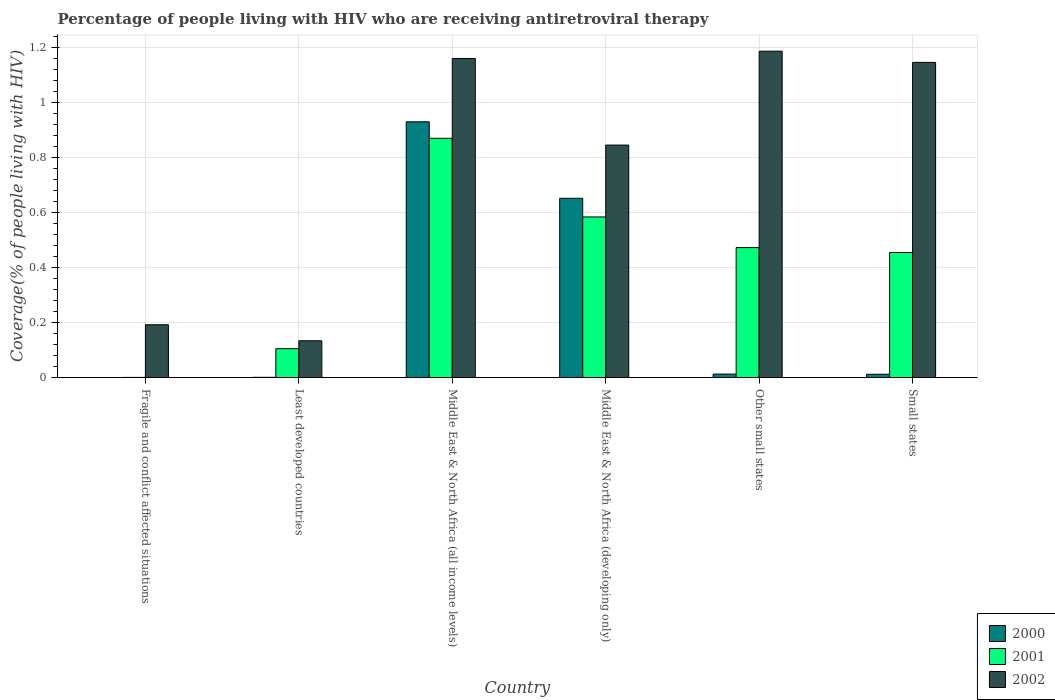How many groups of bars are there?
Give a very brief answer. 6. Are the number of bars per tick equal to the number of legend labels?
Offer a very short reply. Yes. How many bars are there on the 6th tick from the right?
Provide a succinct answer. 3. What is the label of the 3rd group of bars from the left?
Offer a very short reply. Middle East & North Africa (all income levels). In how many cases, is the number of bars for a given country not equal to the number of legend labels?
Keep it short and to the point. 0. What is the percentage of the HIV infected people who are receiving antiretroviral therapy in 2000 in Small states?
Offer a very short reply. 0.01. Across all countries, what is the maximum percentage of the HIV infected people who are receiving antiretroviral therapy in 2000?
Your response must be concise. 0.93. Across all countries, what is the minimum percentage of the HIV infected people who are receiving antiretroviral therapy in 2000?
Your answer should be very brief. 0. In which country was the percentage of the HIV infected people who are receiving antiretroviral therapy in 2000 maximum?
Your answer should be compact. Middle East & North Africa (all income levels). In which country was the percentage of the HIV infected people who are receiving antiretroviral therapy in 2000 minimum?
Your response must be concise. Fragile and conflict affected situations. What is the total percentage of the HIV infected people who are receiving antiretroviral therapy in 2002 in the graph?
Offer a terse response. 4.67. What is the difference between the percentage of the HIV infected people who are receiving antiretroviral therapy in 2000 in Fragile and conflict affected situations and that in Other small states?
Your response must be concise. -0.01. What is the difference between the percentage of the HIV infected people who are receiving antiretroviral therapy in 2001 in Other small states and the percentage of the HIV infected people who are receiving antiretroviral therapy in 2000 in Fragile and conflict affected situations?
Your answer should be very brief. 0.47. What is the average percentage of the HIV infected people who are receiving antiretroviral therapy in 2002 per country?
Your response must be concise. 0.78. What is the difference between the percentage of the HIV infected people who are receiving antiretroviral therapy of/in 2001 and percentage of the HIV infected people who are receiving antiretroviral therapy of/in 2000 in Other small states?
Give a very brief answer. 0.46. What is the ratio of the percentage of the HIV infected people who are receiving antiretroviral therapy in 2001 in Fragile and conflict affected situations to that in Other small states?
Provide a short and direct response. 0. Is the percentage of the HIV infected people who are receiving antiretroviral therapy in 2002 in Middle East & North Africa (all income levels) less than that in Middle East & North Africa (developing only)?
Your response must be concise. No. What is the difference between the highest and the second highest percentage of the HIV infected people who are receiving antiretroviral therapy in 2000?
Provide a succinct answer. 0.28. What is the difference between the highest and the lowest percentage of the HIV infected people who are receiving antiretroviral therapy in 2002?
Your answer should be compact. 1.05. Is the sum of the percentage of the HIV infected people who are receiving antiretroviral therapy in 2002 in Other small states and Small states greater than the maximum percentage of the HIV infected people who are receiving antiretroviral therapy in 2000 across all countries?
Give a very brief answer. Yes. What does the 1st bar from the left in Other small states represents?
Your answer should be compact. 2000. What does the 1st bar from the right in Least developed countries represents?
Keep it short and to the point. 2002. Is it the case that in every country, the sum of the percentage of the HIV infected people who are receiving antiretroviral therapy in 2002 and percentage of the HIV infected people who are receiving antiretroviral therapy in 2000 is greater than the percentage of the HIV infected people who are receiving antiretroviral therapy in 2001?
Provide a succinct answer. Yes. How many countries are there in the graph?
Ensure brevity in your answer.  6. Are the values on the major ticks of Y-axis written in scientific E-notation?
Your response must be concise. No. Does the graph contain any zero values?
Provide a succinct answer. No. Does the graph contain grids?
Provide a succinct answer. Yes. How are the legend labels stacked?
Offer a terse response. Vertical. What is the title of the graph?
Give a very brief answer. Percentage of people living with HIV who are receiving antiretroviral therapy. What is the label or title of the X-axis?
Provide a short and direct response. Country. What is the label or title of the Y-axis?
Your response must be concise. Coverage(% of people living with HIV). What is the Coverage(% of people living with HIV) of 2000 in Fragile and conflict affected situations?
Make the answer very short. 0. What is the Coverage(% of people living with HIV) in 2001 in Fragile and conflict affected situations?
Your answer should be very brief. 0. What is the Coverage(% of people living with HIV) of 2002 in Fragile and conflict affected situations?
Make the answer very short. 0.19. What is the Coverage(% of people living with HIV) of 2000 in Least developed countries?
Offer a very short reply. 0. What is the Coverage(% of people living with HIV) of 2001 in Least developed countries?
Your answer should be very brief. 0.11. What is the Coverage(% of people living with HIV) of 2002 in Least developed countries?
Give a very brief answer. 0.13. What is the Coverage(% of people living with HIV) of 2000 in Middle East & North Africa (all income levels)?
Keep it short and to the point. 0.93. What is the Coverage(% of people living with HIV) of 2001 in Middle East & North Africa (all income levels)?
Provide a short and direct response. 0.87. What is the Coverage(% of people living with HIV) of 2002 in Middle East & North Africa (all income levels)?
Your response must be concise. 1.16. What is the Coverage(% of people living with HIV) of 2000 in Middle East & North Africa (developing only)?
Offer a very short reply. 0.65. What is the Coverage(% of people living with HIV) in 2001 in Middle East & North Africa (developing only)?
Give a very brief answer. 0.58. What is the Coverage(% of people living with HIV) in 2002 in Middle East & North Africa (developing only)?
Offer a very short reply. 0.85. What is the Coverage(% of people living with HIV) in 2000 in Other small states?
Provide a succinct answer. 0.01. What is the Coverage(% of people living with HIV) in 2001 in Other small states?
Make the answer very short. 0.47. What is the Coverage(% of people living with HIV) in 2002 in Other small states?
Offer a very short reply. 1.19. What is the Coverage(% of people living with HIV) in 2000 in Small states?
Give a very brief answer. 0.01. What is the Coverage(% of people living with HIV) in 2001 in Small states?
Give a very brief answer. 0.45. What is the Coverage(% of people living with HIV) in 2002 in Small states?
Provide a succinct answer. 1.15. Across all countries, what is the maximum Coverage(% of people living with HIV) of 2000?
Provide a short and direct response. 0.93. Across all countries, what is the maximum Coverage(% of people living with HIV) in 2001?
Your answer should be compact. 0.87. Across all countries, what is the maximum Coverage(% of people living with HIV) of 2002?
Keep it short and to the point. 1.19. Across all countries, what is the minimum Coverage(% of people living with HIV) in 2000?
Give a very brief answer. 0. Across all countries, what is the minimum Coverage(% of people living with HIV) in 2001?
Ensure brevity in your answer.  0. Across all countries, what is the minimum Coverage(% of people living with HIV) in 2002?
Ensure brevity in your answer.  0.13. What is the total Coverage(% of people living with HIV) in 2000 in the graph?
Provide a short and direct response. 1.61. What is the total Coverage(% of people living with HIV) in 2001 in the graph?
Your response must be concise. 2.49. What is the total Coverage(% of people living with HIV) of 2002 in the graph?
Your answer should be compact. 4.67. What is the difference between the Coverage(% of people living with HIV) in 2000 in Fragile and conflict affected situations and that in Least developed countries?
Offer a very short reply. -0. What is the difference between the Coverage(% of people living with HIV) in 2001 in Fragile and conflict affected situations and that in Least developed countries?
Offer a terse response. -0.1. What is the difference between the Coverage(% of people living with HIV) of 2002 in Fragile and conflict affected situations and that in Least developed countries?
Offer a terse response. 0.06. What is the difference between the Coverage(% of people living with HIV) in 2000 in Fragile and conflict affected situations and that in Middle East & North Africa (all income levels)?
Provide a succinct answer. -0.93. What is the difference between the Coverage(% of people living with HIV) of 2001 in Fragile and conflict affected situations and that in Middle East & North Africa (all income levels)?
Your answer should be very brief. -0.87. What is the difference between the Coverage(% of people living with HIV) of 2002 in Fragile and conflict affected situations and that in Middle East & North Africa (all income levels)?
Make the answer very short. -0.97. What is the difference between the Coverage(% of people living with HIV) of 2000 in Fragile and conflict affected situations and that in Middle East & North Africa (developing only)?
Your response must be concise. -0.65. What is the difference between the Coverage(% of people living with HIV) of 2001 in Fragile and conflict affected situations and that in Middle East & North Africa (developing only)?
Your answer should be very brief. -0.58. What is the difference between the Coverage(% of people living with HIV) in 2002 in Fragile and conflict affected situations and that in Middle East & North Africa (developing only)?
Give a very brief answer. -0.65. What is the difference between the Coverage(% of people living with HIV) in 2000 in Fragile and conflict affected situations and that in Other small states?
Provide a succinct answer. -0.01. What is the difference between the Coverage(% of people living with HIV) of 2001 in Fragile and conflict affected situations and that in Other small states?
Offer a terse response. -0.47. What is the difference between the Coverage(% of people living with HIV) in 2002 in Fragile and conflict affected situations and that in Other small states?
Your answer should be very brief. -0.99. What is the difference between the Coverage(% of people living with HIV) of 2000 in Fragile and conflict affected situations and that in Small states?
Offer a very short reply. -0.01. What is the difference between the Coverage(% of people living with HIV) of 2001 in Fragile and conflict affected situations and that in Small states?
Provide a succinct answer. -0.45. What is the difference between the Coverage(% of people living with HIV) in 2002 in Fragile and conflict affected situations and that in Small states?
Your answer should be very brief. -0.95. What is the difference between the Coverage(% of people living with HIV) of 2000 in Least developed countries and that in Middle East & North Africa (all income levels)?
Your answer should be compact. -0.93. What is the difference between the Coverage(% of people living with HIV) of 2001 in Least developed countries and that in Middle East & North Africa (all income levels)?
Provide a succinct answer. -0.76. What is the difference between the Coverage(% of people living with HIV) of 2002 in Least developed countries and that in Middle East & North Africa (all income levels)?
Your answer should be compact. -1.03. What is the difference between the Coverage(% of people living with HIV) of 2000 in Least developed countries and that in Middle East & North Africa (developing only)?
Keep it short and to the point. -0.65. What is the difference between the Coverage(% of people living with HIV) in 2001 in Least developed countries and that in Middle East & North Africa (developing only)?
Your response must be concise. -0.48. What is the difference between the Coverage(% of people living with HIV) in 2002 in Least developed countries and that in Middle East & North Africa (developing only)?
Provide a short and direct response. -0.71. What is the difference between the Coverage(% of people living with HIV) in 2000 in Least developed countries and that in Other small states?
Your answer should be compact. -0.01. What is the difference between the Coverage(% of people living with HIV) in 2001 in Least developed countries and that in Other small states?
Your answer should be very brief. -0.37. What is the difference between the Coverage(% of people living with HIV) of 2002 in Least developed countries and that in Other small states?
Offer a very short reply. -1.05. What is the difference between the Coverage(% of people living with HIV) of 2000 in Least developed countries and that in Small states?
Offer a very short reply. -0.01. What is the difference between the Coverage(% of people living with HIV) in 2001 in Least developed countries and that in Small states?
Keep it short and to the point. -0.35. What is the difference between the Coverage(% of people living with HIV) in 2002 in Least developed countries and that in Small states?
Your answer should be very brief. -1.01. What is the difference between the Coverage(% of people living with HIV) in 2000 in Middle East & North Africa (all income levels) and that in Middle East & North Africa (developing only)?
Your answer should be very brief. 0.28. What is the difference between the Coverage(% of people living with HIV) of 2001 in Middle East & North Africa (all income levels) and that in Middle East & North Africa (developing only)?
Your answer should be very brief. 0.29. What is the difference between the Coverage(% of people living with HIV) in 2002 in Middle East & North Africa (all income levels) and that in Middle East & North Africa (developing only)?
Provide a succinct answer. 0.31. What is the difference between the Coverage(% of people living with HIV) in 2000 in Middle East & North Africa (all income levels) and that in Other small states?
Ensure brevity in your answer.  0.92. What is the difference between the Coverage(% of people living with HIV) in 2001 in Middle East & North Africa (all income levels) and that in Other small states?
Your answer should be very brief. 0.4. What is the difference between the Coverage(% of people living with HIV) of 2002 in Middle East & North Africa (all income levels) and that in Other small states?
Your answer should be compact. -0.03. What is the difference between the Coverage(% of people living with HIV) in 2000 in Middle East & North Africa (all income levels) and that in Small states?
Give a very brief answer. 0.92. What is the difference between the Coverage(% of people living with HIV) of 2001 in Middle East & North Africa (all income levels) and that in Small states?
Offer a very short reply. 0.42. What is the difference between the Coverage(% of people living with HIV) of 2002 in Middle East & North Africa (all income levels) and that in Small states?
Keep it short and to the point. 0.01. What is the difference between the Coverage(% of people living with HIV) in 2000 in Middle East & North Africa (developing only) and that in Other small states?
Give a very brief answer. 0.64. What is the difference between the Coverage(% of people living with HIV) in 2001 in Middle East & North Africa (developing only) and that in Other small states?
Provide a short and direct response. 0.11. What is the difference between the Coverage(% of people living with HIV) in 2002 in Middle East & North Africa (developing only) and that in Other small states?
Offer a terse response. -0.34. What is the difference between the Coverage(% of people living with HIV) of 2000 in Middle East & North Africa (developing only) and that in Small states?
Your answer should be very brief. 0.64. What is the difference between the Coverage(% of people living with HIV) in 2001 in Middle East & North Africa (developing only) and that in Small states?
Ensure brevity in your answer.  0.13. What is the difference between the Coverage(% of people living with HIV) in 2002 in Middle East & North Africa (developing only) and that in Small states?
Ensure brevity in your answer.  -0.3. What is the difference between the Coverage(% of people living with HIV) in 2000 in Other small states and that in Small states?
Provide a succinct answer. 0. What is the difference between the Coverage(% of people living with HIV) in 2001 in Other small states and that in Small states?
Offer a terse response. 0.02. What is the difference between the Coverage(% of people living with HIV) in 2002 in Other small states and that in Small states?
Your answer should be compact. 0.04. What is the difference between the Coverage(% of people living with HIV) in 2000 in Fragile and conflict affected situations and the Coverage(% of people living with HIV) in 2001 in Least developed countries?
Make the answer very short. -0.1. What is the difference between the Coverage(% of people living with HIV) in 2000 in Fragile and conflict affected situations and the Coverage(% of people living with HIV) in 2002 in Least developed countries?
Your answer should be very brief. -0.13. What is the difference between the Coverage(% of people living with HIV) in 2001 in Fragile and conflict affected situations and the Coverage(% of people living with HIV) in 2002 in Least developed countries?
Provide a succinct answer. -0.13. What is the difference between the Coverage(% of people living with HIV) of 2000 in Fragile and conflict affected situations and the Coverage(% of people living with HIV) of 2001 in Middle East & North Africa (all income levels)?
Provide a succinct answer. -0.87. What is the difference between the Coverage(% of people living with HIV) in 2000 in Fragile and conflict affected situations and the Coverage(% of people living with HIV) in 2002 in Middle East & North Africa (all income levels)?
Provide a short and direct response. -1.16. What is the difference between the Coverage(% of people living with HIV) of 2001 in Fragile and conflict affected situations and the Coverage(% of people living with HIV) of 2002 in Middle East & North Africa (all income levels)?
Offer a terse response. -1.16. What is the difference between the Coverage(% of people living with HIV) of 2000 in Fragile and conflict affected situations and the Coverage(% of people living with HIV) of 2001 in Middle East & North Africa (developing only)?
Offer a very short reply. -0.58. What is the difference between the Coverage(% of people living with HIV) of 2000 in Fragile and conflict affected situations and the Coverage(% of people living with HIV) of 2002 in Middle East & North Africa (developing only)?
Keep it short and to the point. -0.85. What is the difference between the Coverage(% of people living with HIV) of 2001 in Fragile and conflict affected situations and the Coverage(% of people living with HIV) of 2002 in Middle East & North Africa (developing only)?
Provide a succinct answer. -0.84. What is the difference between the Coverage(% of people living with HIV) in 2000 in Fragile and conflict affected situations and the Coverage(% of people living with HIV) in 2001 in Other small states?
Your response must be concise. -0.47. What is the difference between the Coverage(% of people living with HIV) in 2000 in Fragile and conflict affected situations and the Coverage(% of people living with HIV) in 2002 in Other small states?
Your response must be concise. -1.19. What is the difference between the Coverage(% of people living with HIV) of 2001 in Fragile and conflict affected situations and the Coverage(% of people living with HIV) of 2002 in Other small states?
Your answer should be compact. -1.19. What is the difference between the Coverage(% of people living with HIV) of 2000 in Fragile and conflict affected situations and the Coverage(% of people living with HIV) of 2001 in Small states?
Provide a short and direct response. -0.45. What is the difference between the Coverage(% of people living with HIV) of 2000 in Fragile and conflict affected situations and the Coverage(% of people living with HIV) of 2002 in Small states?
Your answer should be very brief. -1.15. What is the difference between the Coverage(% of people living with HIV) of 2001 in Fragile and conflict affected situations and the Coverage(% of people living with HIV) of 2002 in Small states?
Give a very brief answer. -1.15. What is the difference between the Coverage(% of people living with HIV) of 2000 in Least developed countries and the Coverage(% of people living with HIV) of 2001 in Middle East & North Africa (all income levels)?
Provide a succinct answer. -0.87. What is the difference between the Coverage(% of people living with HIV) of 2000 in Least developed countries and the Coverage(% of people living with HIV) of 2002 in Middle East & North Africa (all income levels)?
Offer a terse response. -1.16. What is the difference between the Coverage(% of people living with HIV) of 2001 in Least developed countries and the Coverage(% of people living with HIV) of 2002 in Middle East & North Africa (all income levels)?
Your answer should be very brief. -1.05. What is the difference between the Coverage(% of people living with HIV) of 2000 in Least developed countries and the Coverage(% of people living with HIV) of 2001 in Middle East & North Africa (developing only)?
Give a very brief answer. -0.58. What is the difference between the Coverage(% of people living with HIV) in 2000 in Least developed countries and the Coverage(% of people living with HIV) in 2002 in Middle East & North Africa (developing only)?
Provide a short and direct response. -0.84. What is the difference between the Coverage(% of people living with HIV) of 2001 in Least developed countries and the Coverage(% of people living with HIV) of 2002 in Middle East & North Africa (developing only)?
Ensure brevity in your answer.  -0.74. What is the difference between the Coverage(% of people living with HIV) in 2000 in Least developed countries and the Coverage(% of people living with HIV) in 2001 in Other small states?
Provide a short and direct response. -0.47. What is the difference between the Coverage(% of people living with HIV) of 2000 in Least developed countries and the Coverage(% of people living with HIV) of 2002 in Other small states?
Your answer should be compact. -1.19. What is the difference between the Coverage(% of people living with HIV) of 2001 in Least developed countries and the Coverage(% of people living with HIV) of 2002 in Other small states?
Keep it short and to the point. -1.08. What is the difference between the Coverage(% of people living with HIV) of 2000 in Least developed countries and the Coverage(% of people living with HIV) of 2001 in Small states?
Your answer should be very brief. -0.45. What is the difference between the Coverage(% of people living with HIV) of 2000 in Least developed countries and the Coverage(% of people living with HIV) of 2002 in Small states?
Ensure brevity in your answer.  -1.14. What is the difference between the Coverage(% of people living with HIV) in 2001 in Least developed countries and the Coverage(% of people living with HIV) in 2002 in Small states?
Ensure brevity in your answer.  -1.04. What is the difference between the Coverage(% of people living with HIV) of 2000 in Middle East & North Africa (all income levels) and the Coverage(% of people living with HIV) of 2001 in Middle East & North Africa (developing only)?
Provide a short and direct response. 0.35. What is the difference between the Coverage(% of people living with HIV) of 2000 in Middle East & North Africa (all income levels) and the Coverage(% of people living with HIV) of 2002 in Middle East & North Africa (developing only)?
Keep it short and to the point. 0.08. What is the difference between the Coverage(% of people living with HIV) of 2001 in Middle East & North Africa (all income levels) and the Coverage(% of people living with HIV) of 2002 in Middle East & North Africa (developing only)?
Offer a terse response. 0.02. What is the difference between the Coverage(% of people living with HIV) in 2000 in Middle East & North Africa (all income levels) and the Coverage(% of people living with HIV) in 2001 in Other small states?
Give a very brief answer. 0.46. What is the difference between the Coverage(% of people living with HIV) of 2000 in Middle East & North Africa (all income levels) and the Coverage(% of people living with HIV) of 2002 in Other small states?
Provide a short and direct response. -0.26. What is the difference between the Coverage(% of people living with HIV) of 2001 in Middle East & North Africa (all income levels) and the Coverage(% of people living with HIV) of 2002 in Other small states?
Ensure brevity in your answer.  -0.32. What is the difference between the Coverage(% of people living with HIV) of 2000 in Middle East & North Africa (all income levels) and the Coverage(% of people living with HIV) of 2001 in Small states?
Your response must be concise. 0.48. What is the difference between the Coverage(% of people living with HIV) in 2000 in Middle East & North Africa (all income levels) and the Coverage(% of people living with HIV) in 2002 in Small states?
Keep it short and to the point. -0.22. What is the difference between the Coverage(% of people living with HIV) in 2001 in Middle East & North Africa (all income levels) and the Coverage(% of people living with HIV) in 2002 in Small states?
Offer a terse response. -0.28. What is the difference between the Coverage(% of people living with HIV) of 2000 in Middle East & North Africa (developing only) and the Coverage(% of people living with HIV) of 2001 in Other small states?
Provide a succinct answer. 0.18. What is the difference between the Coverage(% of people living with HIV) of 2000 in Middle East & North Africa (developing only) and the Coverage(% of people living with HIV) of 2002 in Other small states?
Your response must be concise. -0.53. What is the difference between the Coverage(% of people living with HIV) of 2001 in Middle East & North Africa (developing only) and the Coverage(% of people living with HIV) of 2002 in Other small states?
Your answer should be very brief. -0.6. What is the difference between the Coverage(% of people living with HIV) in 2000 in Middle East & North Africa (developing only) and the Coverage(% of people living with HIV) in 2001 in Small states?
Your answer should be compact. 0.2. What is the difference between the Coverage(% of people living with HIV) of 2000 in Middle East & North Africa (developing only) and the Coverage(% of people living with HIV) of 2002 in Small states?
Ensure brevity in your answer.  -0.49. What is the difference between the Coverage(% of people living with HIV) of 2001 in Middle East & North Africa (developing only) and the Coverage(% of people living with HIV) of 2002 in Small states?
Ensure brevity in your answer.  -0.56. What is the difference between the Coverage(% of people living with HIV) of 2000 in Other small states and the Coverage(% of people living with HIV) of 2001 in Small states?
Provide a succinct answer. -0.44. What is the difference between the Coverage(% of people living with HIV) of 2000 in Other small states and the Coverage(% of people living with HIV) of 2002 in Small states?
Provide a succinct answer. -1.13. What is the difference between the Coverage(% of people living with HIV) of 2001 in Other small states and the Coverage(% of people living with HIV) of 2002 in Small states?
Give a very brief answer. -0.67. What is the average Coverage(% of people living with HIV) in 2000 per country?
Make the answer very short. 0.27. What is the average Coverage(% of people living with HIV) of 2001 per country?
Keep it short and to the point. 0.41. What is the average Coverage(% of people living with HIV) in 2002 per country?
Make the answer very short. 0.78. What is the difference between the Coverage(% of people living with HIV) in 2000 and Coverage(% of people living with HIV) in 2001 in Fragile and conflict affected situations?
Your response must be concise. -0. What is the difference between the Coverage(% of people living with HIV) in 2000 and Coverage(% of people living with HIV) in 2002 in Fragile and conflict affected situations?
Make the answer very short. -0.19. What is the difference between the Coverage(% of people living with HIV) in 2001 and Coverage(% of people living with HIV) in 2002 in Fragile and conflict affected situations?
Provide a short and direct response. -0.19. What is the difference between the Coverage(% of people living with HIV) in 2000 and Coverage(% of people living with HIV) in 2001 in Least developed countries?
Your answer should be compact. -0.1. What is the difference between the Coverage(% of people living with HIV) of 2000 and Coverage(% of people living with HIV) of 2002 in Least developed countries?
Offer a terse response. -0.13. What is the difference between the Coverage(% of people living with HIV) in 2001 and Coverage(% of people living with HIV) in 2002 in Least developed countries?
Offer a very short reply. -0.03. What is the difference between the Coverage(% of people living with HIV) in 2000 and Coverage(% of people living with HIV) in 2001 in Middle East & North Africa (all income levels)?
Make the answer very short. 0.06. What is the difference between the Coverage(% of people living with HIV) of 2000 and Coverage(% of people living with HIV) of 2002 in Middle East & North Africa (all income levels)?
Offer a very short reply. -0.23. What is the difference between the Coverage(% of people living with HIV) of 2001 and Coverage(% of people living with HIV) of 2002 in Middle East & North Africa (all income levels)?
Your answer should be compact. -0.29. What is the difference between the Coverage(% of people living with HIV) of 2000 and Coverage(% of people living with HIV) of 2001 in Middle East & North Africa (developing only)?
Your answer should be very brief. 0.07. What is the difference between the Coverage(% of people living with HIV) of 2000 and Coverage(% of people living with HIV) of 2002 in Middle East & North Africa (developing only)?
Offer a terse response. -0.19. What is the difference between the Coverage(% of people living with HIV) in 2001 and Coverage(% of people living with HIV) in 2002 in Middle East & North Africa (developing only)?
Offer a very short reply. -0.26. What is the difference between the Coverage(% of people living with HIV) of 2000 and Coverage(% of people living with HIV) of 2001 in Other small states?
Ensure brevity in your answer.  -0.46. What is the difference between the Coverage(% of people living with HIV) of 2000 and Coverage(% of people living with HIV) of 2002 in Other small states?
Your answer should be very brief. -1.17. What is the difference between the Coverage(% of people living with HIV) in 2001 and Coverage(% of people living with HIV) in 2002 in Other small states?
Make the answer very short. -0.71. What is the difference between the Coverage(% of people living with HIV) in 2000 and Coverage(% of people living with HIV) in 2001 in Small states?
Provide a succinct answer. -0.44. What is the difference between the Coverage(% of people living with HIV) of 2000 and Coverage(% of people living with HIV) of 2002 in Small states?
Give a very brief answer. -1.13. What is the difference between the Coverage(% of people living with HIV) of 2001 and Coverage(% of people living with HIV) of 2002 in Small states?
Ensure brevity in your answer.  -0.69. What is the ratio of the Coverage(% of people living with HIV) of 2000 in Fragile and conflict affected situations to that in Least developed countries?
Provide a short and direct response. 0.36. What is the ratio of the Coverage(% of people living with HIV) in 2001 in Fragile and conflict affected situations to that in Least developed countries?
Provide a succinct answer. 0.01. What is the ratio of the Coverage(% of people living with HIV) in 2002 in Fragile and conflict affected situations to that in Least developed countries?
Make the answer very short. 1.43. What is the ratio of the Coverage(% of people living with HIV) of 2000 in Fragile and conflict affected situations to that in Middle East & North Africa (all income levels)?
Make the answer very short. 0. What is the ratio of the Coverage(% of people living with HIV) of 2001 in Fragile and conflict affected situations to that in Middle East & North Africa (all income levels)?
Offer a very short reply. 0. What is the ratio of the Coverage(% of people living with HIV) in 2002 in Fragile and conflict affected situations to that in Middle East & North Africa (all income levels)?
Keep it short and to the point. 0.17. What is the ratio of the Coverage(% of people living with HIV) in 2000 in Fragile and conflict affected situations to that in Middle East & North Africa (developing only)?
Give a very brief answer. 0. What is the ratio of the Coverage(% of people living with HIV) in 2001 in Fragile and conflict affected situations to that in Middle East & North Africa (developing only)?
Offer a very short reply. 0. What is the ratio of the Coverage(% of people living with HIV) in 2002 in Fragile and conflict affected situations to that in Middle East & North Africa (developing only)?
Offer a terse response. 0.23. What is the ratio of the Coverage(% of people living with HIV) in 2000 in Fragile and conflict affected situations to that in Other small states?
Your answer should be compact. 0.04. What is the ratio of the Coverage(% of people living with HIV) of 2001 in Fragile and conflict affected situations to that in Other small states?
Your response must be concise. 0. What is the ratio of the Coverage(% of people living with HIV) in 2002 in Fragile and conflict affected situations to that in Other small states?
Keep it short and to the point. 0.16. What is the ratio of the Coverage(% of people living with HIV) in 2000 in Fragile and conflict affected situations to that in Small states?
Give a very brief answer. 0.04. What is the ratio of the Coverage(% of people living with HIV) of 2001 in Fragile and conflict affected situations to that in Small states?
Provide a succinct answer. 0. What is the ratio of the Coverage(% of people living with HIV) of 2002 in Fragile and conflict affected situations to that in Small states?
Make the answer very short. 0.17. What is the ratio of the Coverage(% of people living with HIV) of 2000 in Least developed countries to that in Middle East & North Africa (all income levels)?
Your answer should be very brief. 0. What is the ratio of the Coverage(% of people living with HIV) in 2001 in Least developed countries to that in Middle East & North Africa (all income levels)?
Offer a terse response. 0.12. What is the ratio of the Coverage(% of people living with HIV) in 2002 in Least developed countries to that in Middle East & North Africa (all income levels)?
Make the answer very short. 0.12. What is the ratio of the Coverage(% of people living with HIV) in 2000 in Least developed countries to that in Middle East & North Africa (developing only)?
Your response must be concise. 0. What is the ratio of the Coverage(% of people living with HIV) of 2001 in Least developed countries to that in Middle East & North Africa (developing only)?
Your response must be concise. 0.18. What is the ratio of the Coverage(% of people living with HIV) of 2002 in Least developed countries to that in Middle East & North Africa (developing only)?
Provide a short and direct response. 0.16. What is the ratio of the Coverage(% of people living with HIV) of 2000 in Least developed countries to that in Other small states?
Keep it short and to the point. 0.1. What is the ratio of the Coverage(% of people living with HIV) of 2001 in Least developed countries to that in Other small states?
Your response must be concise. 0.22. What is the ratio of the Coverage(% of people living with HIV) of 2002 in Least developed countries to that in Other small states?
Offer a very short reply. 0.11. What is the ratio of the Coverage(% of people living with HIV) of 2000 in Least developed countries to that in Small states?
Give a very brief answer. 0.11. What is the ratio of the Coverage(% of people living with HIV) in 2001 in Least developed countries to that in Small states?
Your response must be concise. 0.23. What is the ratio of the Coverage(% of people living with HIV) in 2002 in Least developed countries to that in Small states?
Make the answer very short. 0.12. What is the ratio of the Coverage(% of people living with HIV) of 2000 in Middle East & North Africa (all income levels) to that in Middle East & North Africa (developing only)?
Your answer should be compact. 1.43. What is the ratio of the Coverage(% of people living with HIV) in 2001 in Middle East & North Africa (all income levels) to that in Middle East & North Africa (developing only)?
Your answer should be compact. 1.49. What is the ratio of the Coverage(% of people living with HIV) in 2002 in Middle East & North Africa (all income levels) to that in Middle East & North Africa (developing only)?
Make the answer very short. 1.37. What is the ratio of the Coverage(% of people living with HIV) in 2000 in Middle East & North Africa (all income levels) to that in Other small states?
Ensure brevity in your answer.  71.51. What is the ratio of the Coverage(% of people living with HIV) in 2001 in Middle East & North Africa (all income levels) to that in Other small states?
Your response must be concise. 1.84. What is the ratio of the Coverage(% of people living with HIV) of 2002 in Middle East & North Africa (all income levels) to that in Other small states?
Your answer should be compact. 0.98. What is the ratio of the Coverage(% of people living with HIV) in 2000 in Middle East & North Africa (all income levels) to that in Small states?
Give a very brief answer. 74.75. What is the ratio of the Coverage(% of people living with HIV) in 2001 in Middle East & North Africa (all income levels) to that in Small states?
Offer a terse response. 1.91. What is the ratio of the Coverage(% of people living with HIV) of 2002 in Middle East & North Africa (all income levels) to that in Small states?
Give a very brief answer. 1.01. What is the ratio of the Coverage(% of people living with HIV) of 2000 in Middle East & North Africa (developing only) to that in Other small states?
Provide a short and direct response. 50.14. What is the ratio of the Coverage(% of people living with HIV) of 2001 in Middle East & North Africa (developing only) to that in Other small states?
Provide a succinct answer. 1.24. What is the ratio of the Coverage(% of people living with HIV) in 2002 in Middle East & North Africa (developing only) to that in Other small states?
Keep it short and to the point. 0.71. What is the ratio of the Coverage(% of people living with HIV) in 2000 in Middle East & North Africa (developing only) to that in Small states?
Your response must be concise. 52.41. What is the ratio of the Coverage(% of people living with HIV) of 2001 in Middle East & North Africa (developing only) to that in Small states?
Make the answer very short. 1.28. What is the ratio of the Coverage(% of people living with HIV) of 2002 in Middle East & North Africa (developing only) to that in Small states?
Offer a very short reply. 0.74. What is the ratio of the Coverage(% of people living with HIV) of 2000 in Other small states to that in Small states?
Your response must be concise. 1.05. What is the ratio of the Coverage(% of people living with HIV) in 2001 in Other small states to that in Small states?
Give a very brief answer. 1.04. What is the ratio of the Coverage(% of people living with HIV) of 2002 in Other small states to that in Small states?
Your answer should be very brief. 1.04. What is the difference between the highest and the second highest Coverage(% of people living with HIV) in 2000?
Offer a very short reply. 0.28. What is the difference between the highest and the second highest Coverage(% of people living with HIV) of 2001?
Your answer should be very brief. 0.29. What is the difference between the highest and the second highest Coverage(% of people living with HIV) in 2002?
Your answer should be compact. 0.03. What is the difference between the highest and the lowest Coverage(% of people living with HIV) in 2000?
Your response must be concise. 0.93. What is the difference between the highest and the lowest Coverage(% of people living with HIV) in 2001?
Give a very brief answer. 0.87. What is the difference between the highest and the lowest Coverage(% of people living with HIV) of 2002?
Your response must be concise. 1.05. 